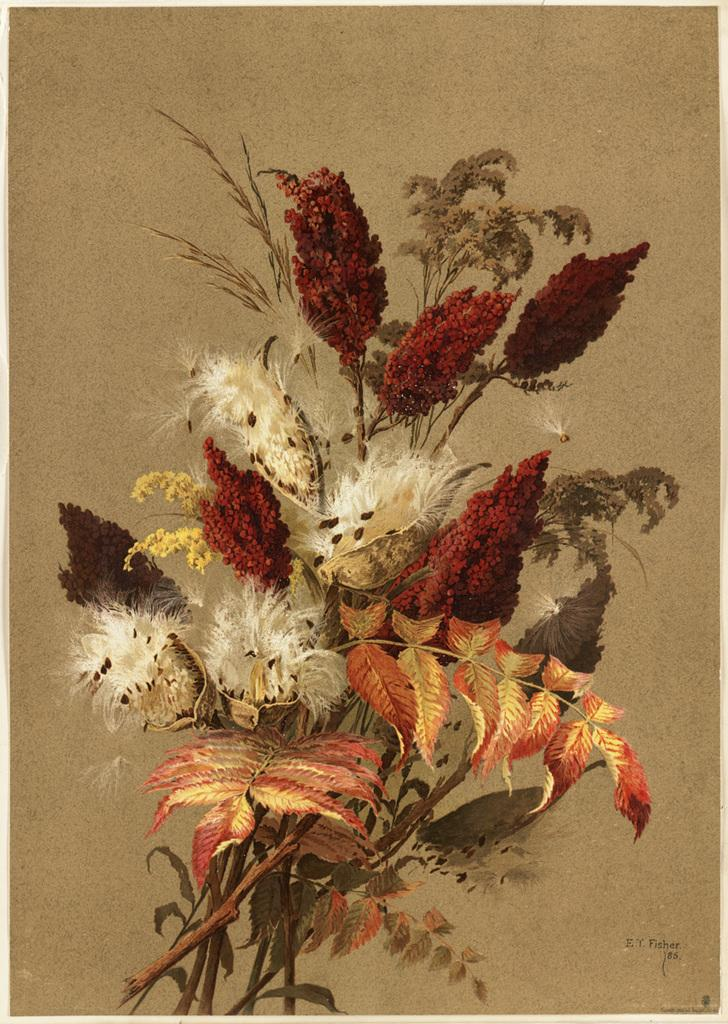What type of artwork is depicted in the image? The image is a painting. What is the main subject of the painting? There is a bouquet in the painting. What are the components of the bouquet? The bouquet has leaves and flowers. What type of board is used to display the bouquet in the painting? There is no board present in the painting; it is a painting of a bouquet, not a display of a bouquet on a board. 